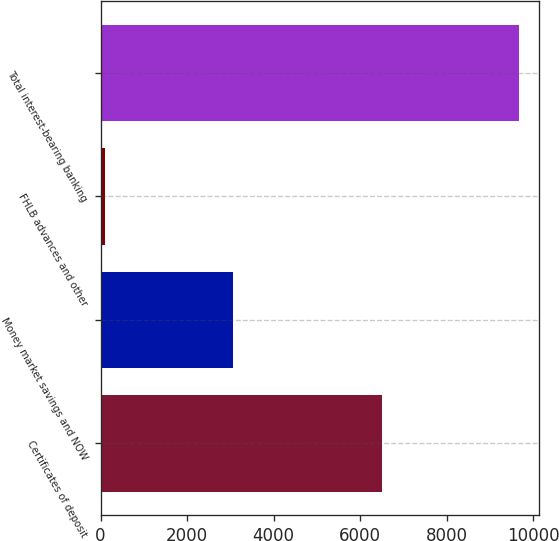Convert chart to OTSL. <chart><loc_0><loc_0><loc_500><loc_500><bar_chart><fcel>Certificates of deposit<fcel>Money market savings and NOW<fcel>FHLB advances and other<fcel>Total interest-bearing banking<nl><fcel>6501<fcel>3060<fcel>98<fcel>9659<nl></chart> 